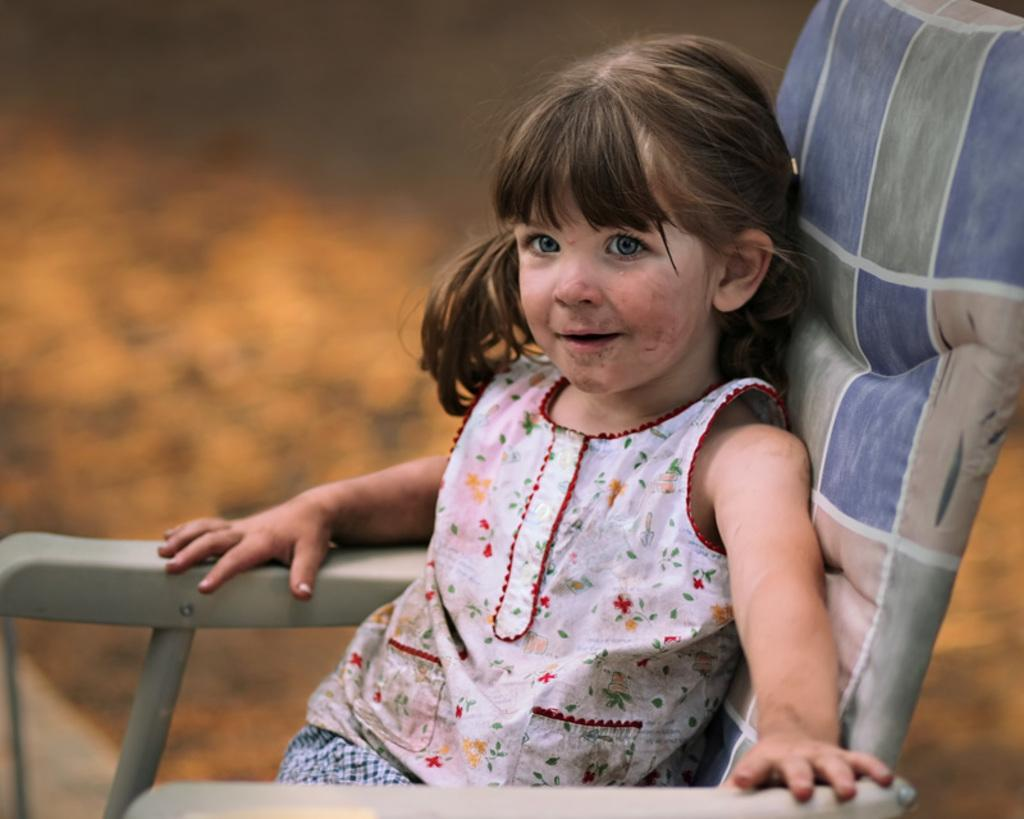Who is the main subject in the image? There is a girl in the image. What is the girl doing in the image? The girl is sitting in a chair. What type of arithmetic problem is the girl solving in the image? There is no indication in the image that the girl is solving an arithmetic problem. What kind of surprise is the girl receiving in the image? There is no surprise present in the image; the girl is simply sitting in a chair. 